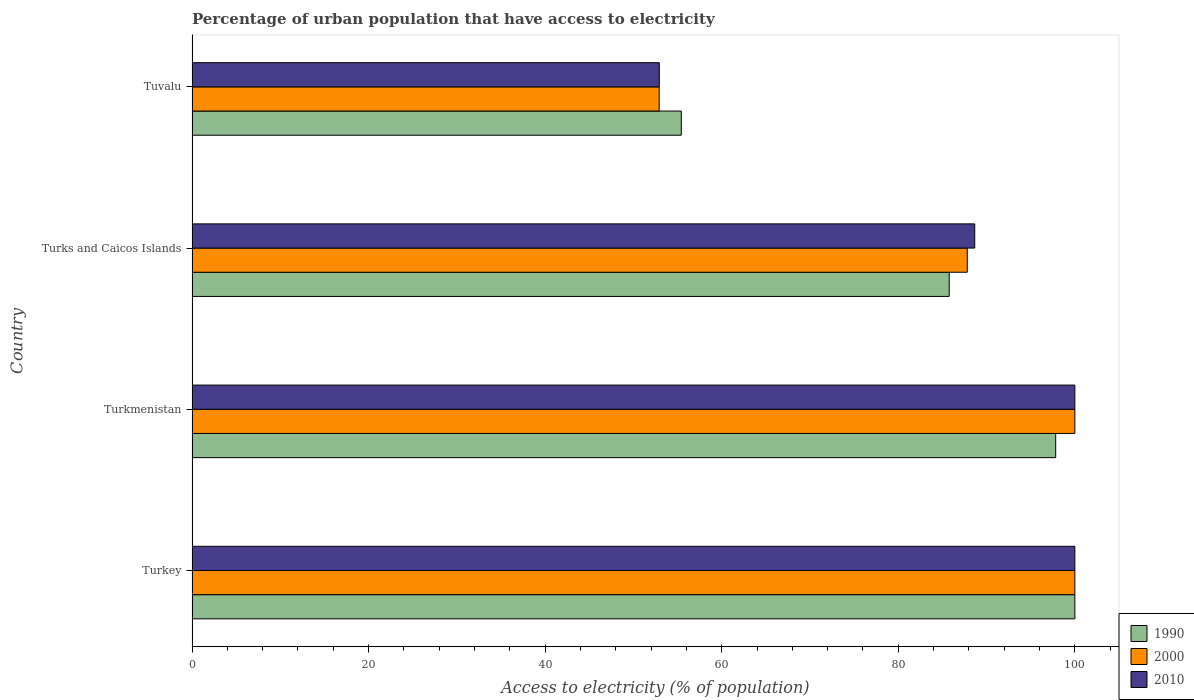Are the number of bars per tick equal to the number of legend labels?
Make the answer very short. Yes. How many bars are there on the 3rd tick from the bottom?
Provide a succinct answer. 3. What is the label of the 4th group of bars from the top?
Give a very brief answer. Turkey. In how many cases, is the number of bars for a given country not equal to the number of legend labels?
Your response must be concise. 0. What is the percentage of urban population that have access to electricity in 2000 in Turks and Caicos Islands?
Your answer should be very brief. 87.81. Across all countries, what is the minimum percentage of urban population that have access to electricity in 1990?
Your response must be concise. 55.42. In which country was the percentage of urban population that have access to electricity in 2000 minimum?
Ensure brevity in your answer.  Tuvalu. What is the total percentage of urban population that have access to electricity in 1990 in the graph?
Ensure brevity in your answer.  339.02. What is the difference between the percentage of urban population that have access to electricity in 2010 in Turkey and that in Turks and Caicos Islands?
Your response must be concise. 11.34. What is the difference between the percentage of urban population that have access to electricity in 2000 in Tuvalu and the percentage of urban population that have access to electricity in 1990 in Turks and Caicos Islands?
Keep it short and to the point. -32.86. What is the average percentage of urban population that have access to electricity in 1990 per country?
Ensure brevity in your answer.  84.75. What is the difference between the percentage of urban population that have access to electricity in 2000 and percentage of urban population that have access to electricity in 1990 in Turkmenistan?
Your answer should be very brief. 2.17. What is the ratio of the percentage of urban population that have access to electricity in 2000 in Turkey to that in Turks and Caicos Islands?
Make the answer very short. 1.14. What is the difference between the highest and the second highest percentage of urban population that have access to electricity in 1990?
Your answer should be compact. 2.17. What is the difference between the highest and the lowest percentage of urban population that have access to electricity in 1990?
Provide a succinct answer. 44.58. Is the sum of the percentage of urban population that have access to electricity in 1990 in Turkey and Turks and Caicos Islands greater than the maximum percentage of urban population that have access to electricity in 2010 across all countries?
Ensure brevity in your answer.  Yes. What does the 1st bar from the top in Turks and Caicos Islands represents?
Make the answer very short. 2010. What does the 2nd bar from the bottom in Turkmenistan represents?
Keep it short and to the point. 2000. Is it the case that in every country, the sum of the percentage of urban population that have access to electricity in 2010 and percentage of urban population that have access to electricity in 2000 is greater than the percentage of urban population that have access to electricity in 1990?
Offer a very short reply. Yes. How many countries are there in the graph?
Make the answer very short. 4. What is the difference between two consecutive major ticks on the X-axis?
Ensure brevity in your answer.  20. Are the values on the major ticks of X-axis written in scientific E-notation?
Your answer should be very brief. No. Does the graph contain grids?
Keep it short and to the point. No. How many legend labels are there?
Offer a terse response. 3. How are the legend labels stacked?
Ensure brevity in your answer.  Vertical. What is the title of the graph?
Make the answer very short. Percentage of urban population that have access to electricity. Does "1996" appear as one of the legend labels in the graph?
Provide a short and direct response. No. What is the label or title of the X-axis?
Ensure brevity in your answer.  Access to electricity (% of population). What is the Access to electricity (% of population) in 1990 in Turkey?
Your answer should be compact. 100. What is the Access to electricity (% of population) of 1990 in Turkmenistan?
Keep it short and to the point. 97.83. What is the Access to electricity (% of population) of 2000 in Turkmenistan?
Provide a succinct answer. 100. What is the Access to electricity (% of population) in 2010 in Turkmenistan?
Your answer should be compact. 100. What is the Access to electricity (% of population) in 1990 in Turks and Caicos Islands?
Your response must be concise. 85.77. What is the Access to electricity (% of population) of 2000 in Turks and Caicos Islands?
Provide a short and direct response. 87.81. What is the Access to electricity (% of population) of 2010 in Turks and Caicos Islands?
Keep it short and to the point. 88.66. What is the Access to electricity (% of population) in 1990 in Tuvalu?
Provide a succinct answer. 55.42. What is the Access to electricity (% of population) of 2000 in Tuvalu?
Offer a terse response. 52.91. What is the Access to electricity (% of population) of 2010 in Tuvalu?
Your response must be concise. 52.93. Across all countries, what is the maximum Access to electricity (% of population) of 1990?
Ensure brevity in your answer.  100. Across all countries, what is the minimum Access to electricity (% of population) of 1990?
Give a very brief answer. 55.42. Across all countries, what is the minimum Access to electricity (% of population) of 2000?
Your answer should be very brief. 52.91. Across all countries, what is the minimum Access to electricity (% of population) in 2010?
Your answer should be compact. 52.93. What is the total Access to electricity (% of population) in 1990 in the graph?
Offer a terse response. 339.02. What is the total Access to electricity (% of population) of 2000 in the graph?
Your answer should be very brief. 340.72. What is the total Access to electricity (% of population) of 2010 in the graph?
Ensure brevity in your answer.  341.59. What is the difference between the Access to electricity (% of population) in 1990 in Turkey and that in Turkmenistan?
Offer a terse response. 2.17. What is the difference between the Access to electricity (% of population) of 2010 in Turkey and that in Turkmenistan?
Your answer should be very brief. 0. What is the difference between the Access to electricity (% of population) in 1990 in Turkey and that in Turks and Caicos Islands?
Keep it short and to the point. 14.23. What is the difference between the Access to electricity (% of population) in 2000 in Turkey and that in Turks and Caicos Islands?
Make the answer very short. 12.19. What is the difference between the Access to electricity (% of population) of 2010 in Turkey and that in Turks and Caicos Islands?
Ensure brevity in your answer.  11.34. What is the difference between the Access to electricity (% of population) in 1990 in Turkey and that in Tuvalu?
Make the answer very short. 44.58. What is the difference between the Access to electricity (% of population) in 2000 in Turkey and that in Tuvalu?
Provide a succinct answer. 47.09. What is the difference between the Access to electricity (% of population) of 2010 in Turkey and that in Tuvalu?
Give a very brief answer. 47.07. What is the difference between the Access to electricity (% of population) of 1990 in Turkmenistan and that in Turks and Caicos Islands?
Make the answer very short. 12.06. What is the difference between the Access to electricity (% of population) in 2000 in Turkmenistan and that in Turks and Caicos Islands?
Your answer should be compact. 12.19. What is the difference between the Access to electricity (% of population) in 2010 in Turkmenistan and that in Turks and Caicos Islands?
Your answer should be compact. 11.34. What is the difference between the Access to electricity (% of population) in 1990 in Turkmenistan and that in Tuvalu?
Your response must be concise. 42.41. What is the difference between the Access to electricity (% of population) in 2000 in Turkmenistan and that in Tuvalu?
Provide a short and direct response. 47.09. What is the difference between the Access to electricity (% of population) of 2010 in Turkmenistan and that in Tuvalu?
Ensure brevity in your answer.  47.07. What is the difference between the Access to electricity (% of population) of 1990 in Turks and Caicos Islands and that in Tuvalu?
Offer a terse response. 30.35. What is the difference between the Access to electricity (% of population) in 2000 in Turks and Caicos Islands and that in Tuvalu?
Offer a very short reply. 34.9. What is the difference between the Access to electricity (% of population) of 2010 in Turks and Caicos Islands and that in Tuvalu?
Offer a very short reply. 35.73. What is the difference between the Access to electricity (% of population) of 1990 in Turkey and the Access to electricity (% of population) of 2000 in Turkmenistan?
Provide a short and direct response. 0. What is the difference between the Access to electricity (% of population) in 1990 in Turkey and the Access to electricity (% of population) in 2010 in Turkmenistan?
Offer a very short reply. 0. What is the difference between the Access to electricity (% of population) in 1990 in Turkey and the Access to electricity (% of population) in 2000 in Turks and Caicos Islands?
Ensure brevity in your answer.  12.19. What is the difference between the Access to electricity (% of population) of 1990 in Turkey and the Access to electricity (% of population) of 2010 in Turks and Caicos Islands?
Your response must be concise. 11.34. What is the difference between the Access to electricity (% of population) in 2000 in Turkey and the Access to electricity (% of population) in 2010 in Turks and Caicos Islands?
Make the answer very short. 11.34. What is the difference between the Access to electricity (% of population) of 1990 in Turkey and the Access to electricity (% of population) of 2000 in Tuvalu?
Keep it short and to the point. 47.09. What is the difference between the Access to electricity (% of population) in 1990 in Turkey and the Access to electricity (% of population) in 2010 in Tuvalu?
Make the answer very short. 47.07. What is the difference between the Access to electricity (% of population) in 2000 in Turkey and the Access to electricity (% of population) in 2010 in Tuvalu?
Ensure brevity in your answer.  47.07. What is the difference between the Access to electricity (% of population) of 1990 in Turkmenistan and the Access to electricity (% of population) of 2000 in Turks and Caicos Islands?
Keep it short and to the point. 10.02. What is the difference between the Access to electricity (% of population) of 1990 in Turkmenistan and the Access to electricity (% of population) of 2010 in Turks and Caicos Islands?
Provide a short and direct response. 9.17. What is the difference between the Access to electricity (% of population) of 2000 in Turkmenistan and the Access to electricity (% of population) of 2010 in Turks and Caicos Islands?
Provide a succinct answer. 11.34. What is the difference between the Access to electricity (% of population) of 1990 in Turkmenistan and the Access to electricity (% of population) of 2000 in Tuvalu?
Your answer should be compact. 44.92. What is the difference between the Access to electricity (% of population) of 1990 in Turkmenistan and the Access to electricity (% of population) of 2010 in Tuvalu?
Give a very brief answer. 44.9. What is the difference between the Access to electricity (% of population) in 2000 in Turkmenistan and the Access to electricity (% of population) in 2010 in Tuvalu?
Ensure brevity in your answer.  47.07. What is the difference between the Access to electricity (% of population) in 1990 in Turks and Caicos Islands and the Access to electricity (% of population) in 2000 in Tuvalu?
Give a very brief answer. 32.86. What is the difference between the Access to electricity (% of population) of 1990 in Turks and Caicos Islands and the Access to electricity (% of population) of 2010 in Tuvalu?
Offer a very short reply. 32.84. What is the difference between the Access to electricity (% of population) of 2000 in Turks and Caicos Islands and the Access to electricity (% of population) of 2010 in Tuvalu?
Your answer should be very brief. 34.88. What is the average Access to electricity (% of population) of 1990 per country?
Your response must be concise. 84.75. What is the average Access to electricity (% of population) in 2000 per country?
Your answer should be very brief. 85.18. What is the average Access to electricity (% of population) of 2010 per country?
Offer a very short reply. 85.4. What is the difference between the Access to electricity (% of population) in 1990 and Access to electricity (% of population) in 2000 in Turkey?
Provide a short and direct response. 0. What is the difference between the Access to electricity (% of population) in 2000 and Access to electricity (% of population) in 2010 in Turkey?
Provide a succinct answer. 0. What is the difference between the Access to electricity (% of population) of 1990 and Access to electricity (% of population) of 2000 in Turkmenistan?
Your answer should be very brief. -2.17. What is the difference between the Access to electricity (% of population) in 1990 and Access to electricity (% of population) in 2010 in Turkmenistan?
Provide a short and direct response. -2.17. What is the difference between the Access to electricity (% of population) of 1990 and Access to electricity (% of population) of 2000 in Turks and Caicos Islands?
Your answer should be compact. -2.04. What is the difference between the Access to electricity (% of population) of 1990 and Access to electricity (% of population) of 2010 in Turks and Caicos Islands?
Your response must be concise. -2.89. What is the difference between the Access to electricity (% of population) in 2000 and Access to electricity (% of population) in 2010 in Turks and Caicos Islands?
Give a very brief answer. -0.85. What is the difference between the Access to electricity (% of population) in 1990 and Access to electricity (% of population) in 2000 in Tuvalu?
Your answer should be compact. 2.51. What is the difference between the Access to electricity (% of population) of 1990 and Access to electricity (% of population) of 2010 in Tuvalu?
Keep it short and to the point. 2.49. What is the difference between the Access to electricity (% of population) of 2000 and Access to electricity (% of population) of 2010 in Tuvalu?
Provide a short and direct response. -0.02. What is the ratio of the Access to electricity (% of population) of 1990 in Turkey to that in Turkmenistan?
Your answer should be very brief. 1.02. What is the ratio of the Access to electricity (% of population) of 2000 in Turkey to that in Turkmenistan?
Keep it short and to the point. 1. What is the ratio of the Access to electricity (% of population) of 2010 in Turkey to that in Turkmenistan?
Your response must be concise. 1. What is the ratio of the Access to electricity (% of population) of 1990 in Turkey to that in Turks and Caicos Islands?
Give a very brief answer. 1.17. What is the ratio of the Access to electricity (% of population) of 2000 in Turkey to that in Turks and Caicos Islands?
Offer a terse response. 1.14. What is the ratio of the Access to electricity (% of population) in 2010 in Turkey to that in Turks and Caicos Islands?
Keep it short and to the point. 1.13. What is the ratio of the Access to electricity (% of population) of 1990 in Turkey to that in Tuvalu?
Offer a very short reply. 1.8. What is the ratio of the Access to electricity (% of population) in 2000 in Turkey to that in Tuvalu?
Your answer should be very brief. 1.89. What is the ratio of the Access to electricity (% of population) of 2010 in Turkey to that in Tuvalu?
Your answer should be very brief. 1.89. What is the ratio of the Access to electricity (% of population) in 1990 in Turkmenistan to that in Turks and Caicos Islands?
Provide a succinct answer. 1.14. What is the ratio of the Access to electricity (% of population) in 2000 in Turkmenistan to that in Turks and Caicos Islands?
Make the answer very short. 1.14. What is the ratio of the Access to electricity (% of population) in 2010 in Turkmenistan to that in Turks and Caicos Islands?
Your answer should be compact. 1.13. What is the ratio of the Access to electricity (% of population) in 1990 in Turkmenistan to that in Tuvalu?
Offer a very short reply. 1.77. What is the ratio of the Access to electricity (% of population) in 2000 in Turkmenistan to that in Tuvalu?
Provide a short and direct response. 1.89. What is the ratio of the Access to electricity (% of population) of 2010 in Turkmenistan to that in Tuvalu?
Your response must be concise. 1.89. What is the ratio of the Access to electricity (% of population) in 1990 in Turks and Caicos Islands to that in Tuvalu?
Your answer should be very brief. 1.55. What is the ratio of the Access to electricity (% of population) of 2000 in Turks and Caicos Islands to that in Tuvalu?
Offer a very short reply. 1.66. What is the ratio of the Access to electricity (% of population) in 2010 in Turks and Caicos Islands to that in Tuvalu?
Make the answer very short. 1.68. What is the difference between the highest and the second highest Access to electricity (% of population) in 1990?
Provide a succinct answer. 2.17. What is the difference between the highest and the second highest Access to electricity (% of population) of 2010?
Offer a terse response. 0. What is the difference between the highest and the lowest Access to electricity (% of population) of 1990?
Offer a terse response. 44.58. What is the difference between the highest and the lowest Access to electricity (% of population) in 2000?
Offer a terse response. 47.09. What is the difference between the highest and the lowest Access to electricity (% of population) in 2010?
Keep it short and to the point. 47.07. 